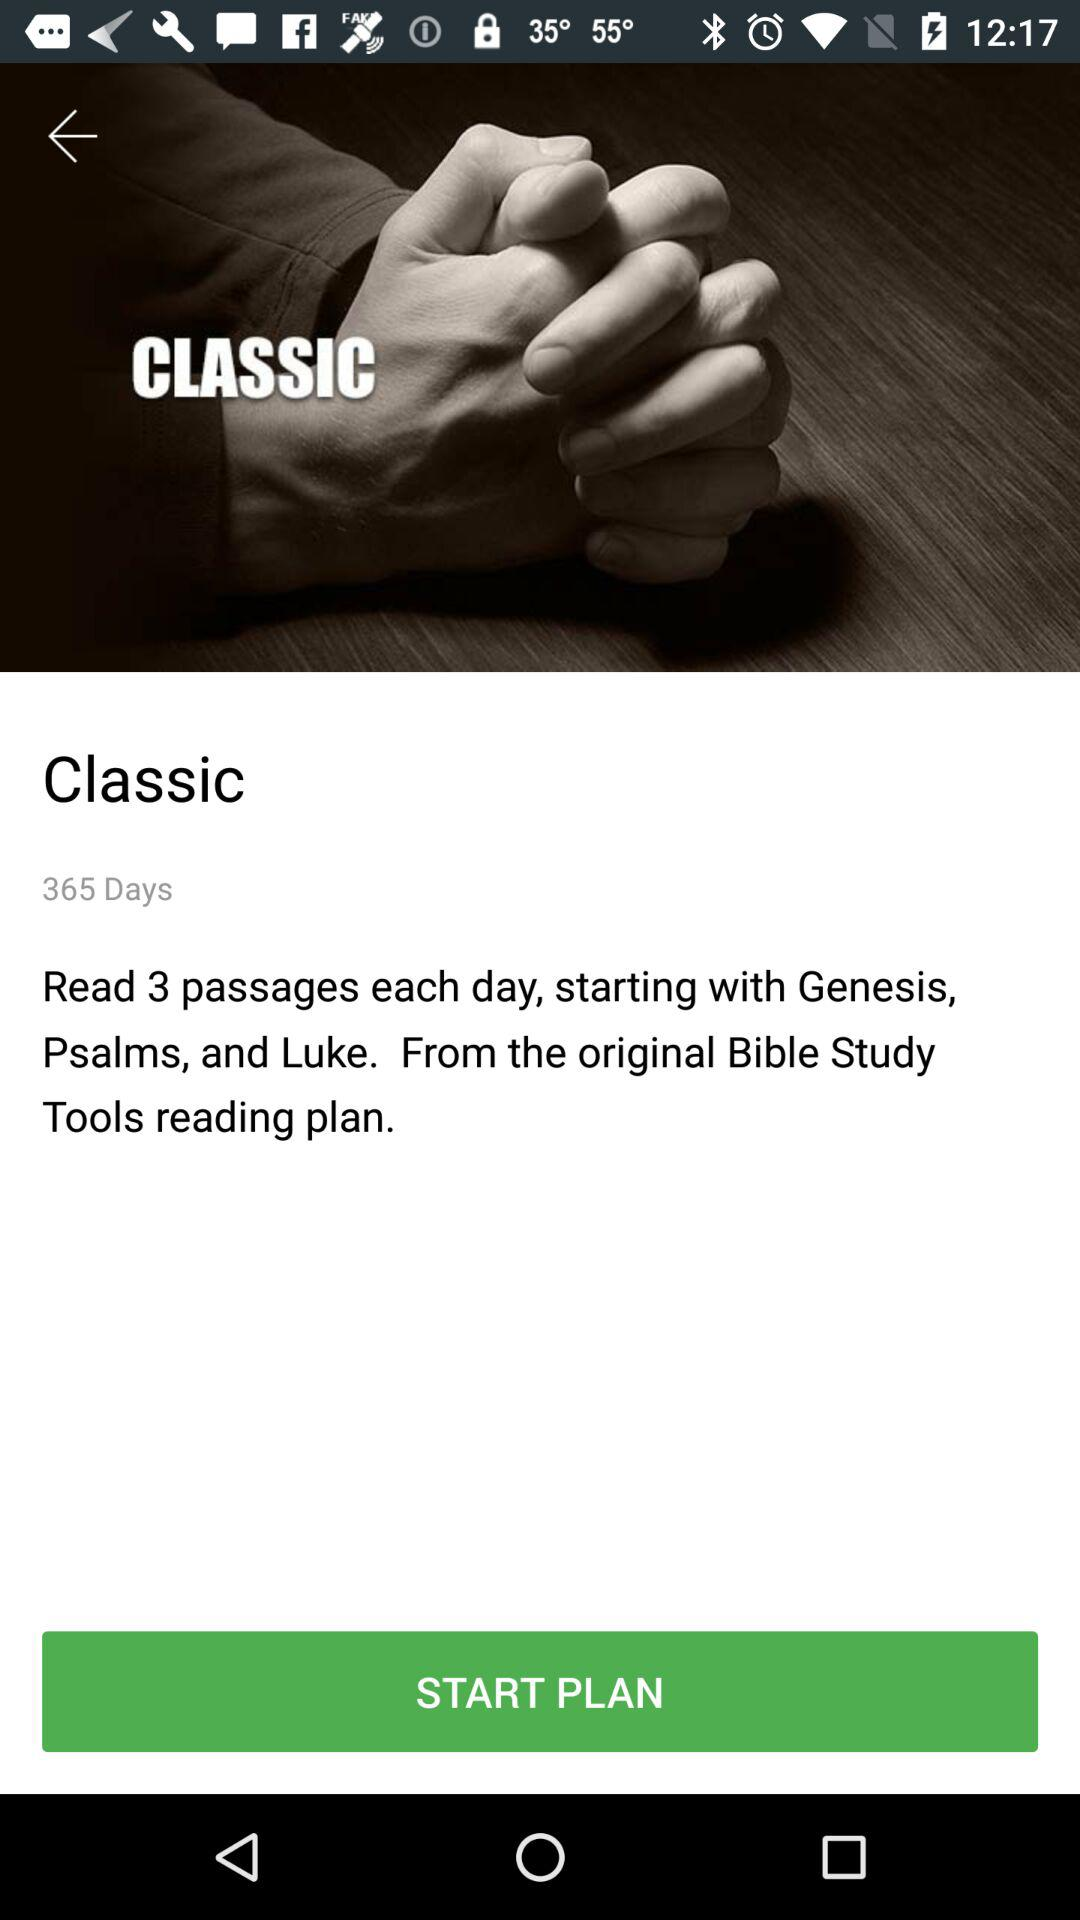How many passages do we have to read each day? You have to read 3 passages each day. 